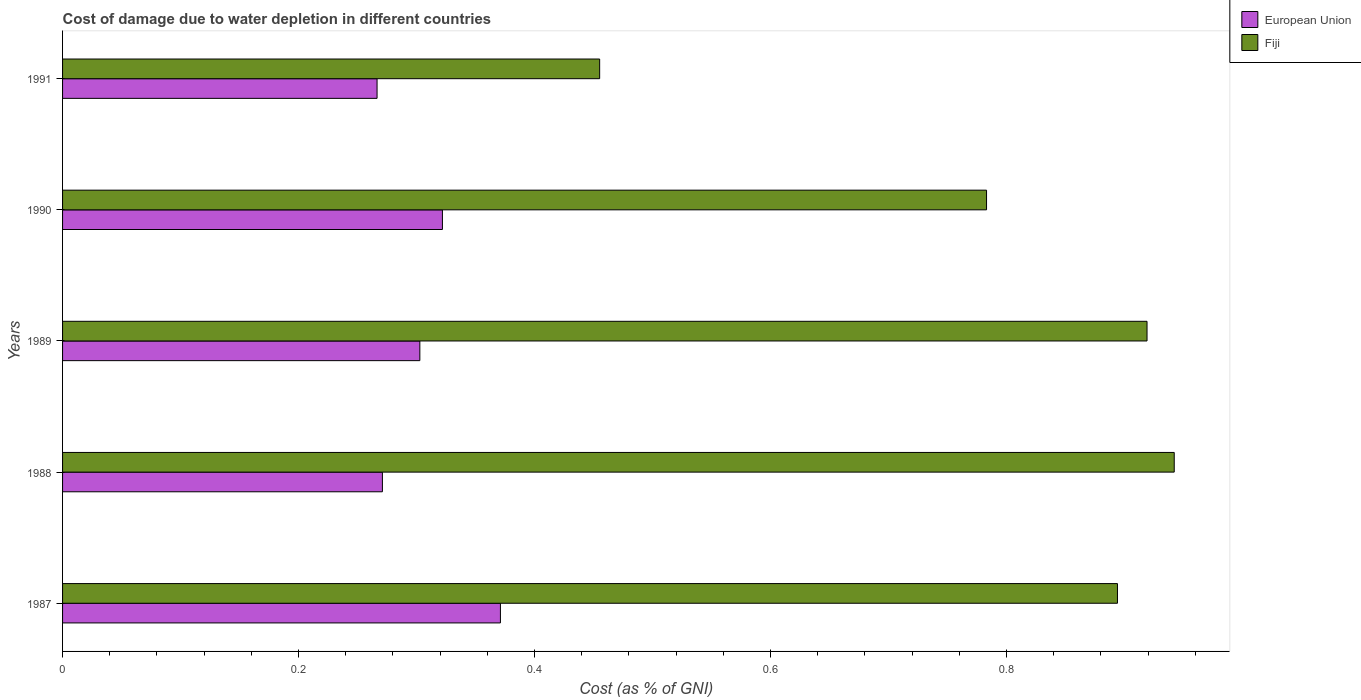How many groups of bars are there?
Your answer should be very brief. 5. How many bars are there on the 1st tick from the bottom?
Provide a short and direct response. 2. What is the label of the 2nd group of bars from the top?
Your answer should be very brief. 1990. In how many cases, is the number of bars for a given year not equal to the number of legend labels?
Provide a short and direct response. 0. What is the cost of damage caused due to water depletion in European Union in 1987?
Provide a short and direct response. 0.37. Across all years, what is the maximum cost of damage caused due to water depletion in European Union?
Your response must be concise. 0.37. Across all years, what is the minimum cost of damage caused due to water depletion in Fiji?
Make the answer very short. 0.46. What is the total cost of damage caused due to water depletion in Fiji in the graph?
Your response must be concise. 3.99. What is the difference between the cost of damage caused due to water depletion in European Union in 1988 and that in 1989?
Offer a terse response. -0.03. What is the difference between the cost of damage caused due to water depletion in European Union in 1991 and the cost of damage caused due to water depletion in Fiji in 1989?
Keep it short and to the point. -0.65. What is the average cost of damage caused due to water depletion in Fiji per year?
Provide a succinct answer. 0.8. In the year 1990, what is the difference between the cost of damage caused due to water depletion in European Union and cost of damage caused due to water depletion in Fiji?
Keep it short and to the point. -0.46. In how many years, is the cost of damage caused due to water depletion in European Union greater than 0.08 %?
Keep it short and to the point. 5. What is the ratio of the cost of damage caused due to water depletion in Fiji in 1988 to that in 1990?
Keep it short and to the point. 1.2. Is the cost of damage caused due to water depletion in European Union in 1987 less than that in 1989?
Ensure brevity in your answer.  No. Is the difference between the cost of damage caused due to water depletion in European Union in 1987 and 1989 greater than the difference between the cost of damage caused due to water depletion in Fiji in 1987 and 1989?
Provide a succinct answer. Yes. What is the difference between the highest and the second highest cost of damage caused due to water depletion in Fiji?
Keep it short and to the point. 0.02. What is the difference between the highest and the lowest cost of damage caused due to water depletion in Fiji?
Provide a short and direct response. 0.49. What does the 1st bar from the top in 1988 represents?
Make the answer very short. Fiji. What does the 2nd bar from the bottom in 1991 represents?
Make the answer very short. Fiji. How many bars are there?
Keep it short and to the point. 10. Are all the bars in the graph horizontal?
Your answer should be very brief. Yes. How many years are there in the graph?
Provide a short and direct response. 5. What is the difference between two consecutive major ticks on the X-axis?
Your answer should be compact. 0.2. Does the graph contain grids?
Offer a terse response. No. How many legend labels are there?
Your response must be concise. 2. How are the legend labels stacked?
Your answer should be compact. Vertical. What is the title of the graph?
Offer a very short reply. Cost of damage due to water depletion in different countries. What is the label or title of the X-axis?
Ensure brevity in your answer.  Cost (as % of GNI). What is the Cost (as % of GNI) of European Union in 1987?
Provide a succinct answer. 0.37. What is the Cost (as % of GNI) in Fiji in 1987?
Provide a succinct answer. 0.89. What is the Cost (as % of GNI) in European Union in 1988?
Offer a terse response. 0.27. What is the Cost (as % of GNI) in Fiji in 1988?
Your answer should be compact. 0.94. What is the Cost (as % of GNI) in European Union in 1989?
Your response must be concise. 0.3. What is the Cost (as % of GNI) of Fiji in 1989?
Ensure brevity in your answer.  0.92. What is the Cost (as % of GNI) of European Union in 1990?
Your answer should be compact. 0.32. What is the Cost (as % of GNI) of Fiji in 1990?
Keep it short and to the point. 0.78. What is the Cost (as % of GNI) in European Union in 1991?
Make the answer very short. 0.27. What is the Cost (as % of GNI) of Fiji in 1991?
Give a very brief answer. 0.46. Across all years, what is the maximum Cost (as % of GNI) in European Union?
Ensure brevity in your answer.  0.37. Across all years, what is the maximum Cost (as % of GNI) in Fiji?
Ensure brevity in your answer.  0.94. Across all years, what is the minimum Cost (as % of GNI) in European Union?
Ensure brevity in your answer.  0.27. Across all years, what is the minimum Cost (as % of GNI) in Fiji?
Provide a succinct answer. 0.46. What is the total Cost (as % of GNI) in European Union in the graph?
Make the answer very short. 1.53. What is the total Cost (as % of GNI) in Fiji in the graph?
Provide a short and direct response. 3.99. What is the difference between the Cost (as % of GNI) in European Union in 1987 and that in 1988?
Offer a terse response. 0.1. What is the difference between the Cost (as % of GNI) of Fiji in 1987 and that in 1988?
Your answer should be compact. -0.05. What is the difference between the Cost (as % of GNI) in European Union in 1987 and that in 1989?
Provide a succinct answer. 0.07. What is the difference between the Cost (as % of GNI) in Fiji in 1987 and that in 1989?
Offer a very short reply. -0.03. What is the difference between the Cost (as % of GNI) in European Union in 1987 and that in 1990?
Keep it short and to the point. 0.05. What is the difference between the Cost (as % of GNI) in Fiji in 1987 and that in 1990?
Your answer should be very brief. 0.11. What is the difference between the Cost (as % of GNI) in European Union in 1987 and that in 1991?
Provide a succinct answer. 0.1. What is the difference between the Cost (as % of GNI) of Fiji in 1987 and that in 1991?
Provide a succinct answer. 0.44. What is the difference between the Cost (as % of GNI) in European Union in 1988 and that in 1989?
Your response must be concise. -0.03. What is the difference between the Cost (as % of GNI) in Fiji in 1988 and that in 1989?
Make the answer very short. 0.02. What is the difference between the Cost (as % of GNI) of European Union in 1988 and that in 1990?
Provide a short and direct response. -0.05. What is the difference between the Cost (as % of GNI) of Fiji in 1988 and that in 1990?
Keep it short and to the point. 0.16. What is the difference between the Cost (as % of GNI) in European Union in 1988 and that in 1991?
Your answer should be very brief. 0. What is the difference between the Cost (as % of GNI) of Fiji in 1988 and that in 1991?
Ensure brevity in your answer.  0.49. What is the difference between the Cost (as % of GNI) of European Union in 1989 and that in 1990?
Offer a very short reply. -0.02. What is the difference between the Cost (as % of GNI) in Fiji in 1989 and that in 1990?
Ensure brevity in your answer.  0.14. What is the difference between the Cost (as % of GNI) in European Union in 1989 and that in 1991?
Make the answer very short. 0.04. What is the difference between the Cost (as % of GNI) in Fiji in 1989 and that in 1991?
Make the answer very short. 0.46. What is the difference between the Cost (as % of GNI) in European Union in 1990 and that in 1991?
Your answer should be very brief. 0.06. What is the difference between the Cost (as % of GNI) in Fiji in 1990 and that in 1991?
Your answer should be compact. 0.33. What is the difference between the Cost (as % of GNI) in European Union in 1987 and the Cost (as % of GNI) in Fiji in 1988?
Offer a very short reply. -0.57. What is the difference between the Cost (as % of GNI) in European Union in 1987 and the Cost (as % of GNI) in Fiji in 1989?
Your answer should be very brief. -0.55. What is the difference between the Cost (as % of GNI) of European Union in 1987 and the Cost (as % of GNI) of Fiji in 1990?
Provide a short and direct response. -0.41. What is the difference between the Cost (as % of GNI) in European Union in 1987 and the Cost (as % of GNI) in Fiji in 1991?
Your response must be concise. -0.08. What is the difference between the Cost (as % of GNI) of European Union in 1988 and the Cost (as % of GNI) of Fiji in 1989?
Offer a terse response. -0.65. What is the difference between the Cost (as % of GNI) in European Union in 1988 and the Cost (as % of GNI) in Fiji in 1990?
Your answer should be compact. -0.51. What is the difference between the Cost (as % of GNI) of European Union in 1988 and the Cost (as % of GNI) of Fiji in 1991?
Your answer should be compact. -0.18. What is the difference between the Cost (as % of GNI) of European Union in 1989 and the Cost (as % of GNI) of Fiji in 1990?
Provide a succinct answer. -0.48. What is the difference between the Cost (as % of GNI) of European Union in 1989 and the Cost (as % of GNI) of Fiji in 1991?
Your answer should be very brief. -0.15. What is the difference between the Cost (as % of GNI) of European Union in 1990 and the Cost (as % of GNI) of Fiji in 1991?
Your answer should be compact. -0.13. What is the average Cost (as % of GNI) of European Union per year?
Provide a short and direct response. 0.31. What is the average Cost (as % of GNI) in Fiji per year?
Keep it short and to the point. 0.8. In the year 1987, what is the difference between the Cost (as % of GNI) of European Union and Cost (as % of GNI) of Fiji?
Provide a succinct answer. -0.52. In the year 1988, what is the difference between the Cost (as % of GNI) of European Union and Cost (as % of GNI) of Fiji?
Give a very brief answer. -0.67. In the year 1989, what is the difference between the Cost (as % of GNI) in European Union and Cost (as % of GNI) in Fiji?
Offer a very short reply. -0.62. In the year 1990, what is the difference between the Cost (as % of GNI) of European Union and Cost (as % of GNI) of Fiji?
Your response must be concise. -0.46. In the year 1991, what is the difference between the Cost (as % of GNI) in European Union and Cost (as % of GNI) in Fiji?
Your answer should be compact. -0.19. What is the ratio of the Cost (as % of GNI) of European Union in 1987 to that in 1988?
Your answer should be compact. 1.37. What is the ratio of the Cost (as % of GNI) of Fiji in 1987 to that in 1988?
Give a very brief answer. 0.95. What is the ratio of the Cost (as % of GNI) in European Union in 1987 to that in 1989?
Ensure brevity in your answer.  1.23. What is the ratio of the Cost (as % of GNI) of Fiji in 1987 to that in 1989?
Offer a very short reply. 0.97. What is the ratio of the Cost (as % of GNI) in European Union in 1987 to that in 1990?
Keep it short and to the point. 1.15. What is the ratio of the Cost (as % of GNI) of Fiji in 1987 to that in 1990?
Make the answer very short. 1.14. What is the ratio of the Cost (as % of GNI) in European Union in 1987 to that in 1991?
Offer a terse response. 1.39. What is the ratio of the Cost (as % of GNI) of Fiji in 1987 to that in 1991?
Your response must be concise. 1.96. What is the ratio of the Cost (as % of GNI) of European Union in 1988 to that in 1989?
Your answer should be compact. 0.9. What is the ratio of the Cost (as % of GNI) in Fiji in 1988 to that in 1989?
Your response must be concise. 1.03. What is the ratio of the Cost (as % of GNI) in European Union in 1988 to that in 1990?
Provide a short and direct response. 0.84. What is the ratio of the Cost (as % of GNI) in Fiji in 1988 to that in 1990?
Provide a short and direct response. 1.2. What is the ratio of the Cost (as % of GNI) in European Union in 1988 to that in 1991?
Make the answer very short. 1.02. What is the ratio of the Cost (as % of GNI) of Fiji in 1988 to that in 1991?
Give a very brief answer. 2.07. What is the ratio of the Cost (as % of GNI) in European Union in 1989 to that in 1990?
Your answer should be very brief. 0.94. What is the ratio of the Cost (as % of GNI) in Fiji in 1989 to that in 1990?
Offer a terse response. 1.17. What is the ratio of the Cost (as % of GNI) in European Union in 1989 to that in 1991?
Offer a very short reply. 1.14. What is the ratio of the Cost (as % of GNI) of Fiji in 1989 to that in 1991?
Give a very brief answer. 2.02. What is the ratio of the Cost (as % of GNI) in European Union in 1990 to that in 1991?
Your answer should be compact. 1.21. What is the ratio of the Cost (as % of GNI) of Fiji in 1990 to that in 1991?
Your answer should be very brief. 1.72. What is the difference between the highest and the second highest Cost (as % of GNI) of European Union?
Offer a terse response. 0.05. What is the difference between the highest and the second highest Cost (as % of GNI) in Fiji?
Your response must be concise. 0.02. What is the difference between the highest and the lowest Cost (as % of GNI) in European Union?
Keep it short and to the point. 0.1. What is the difference between the highest and the lowest Cost (as % of GNI) in Fiji?
Your response must be concise. 0.49. 